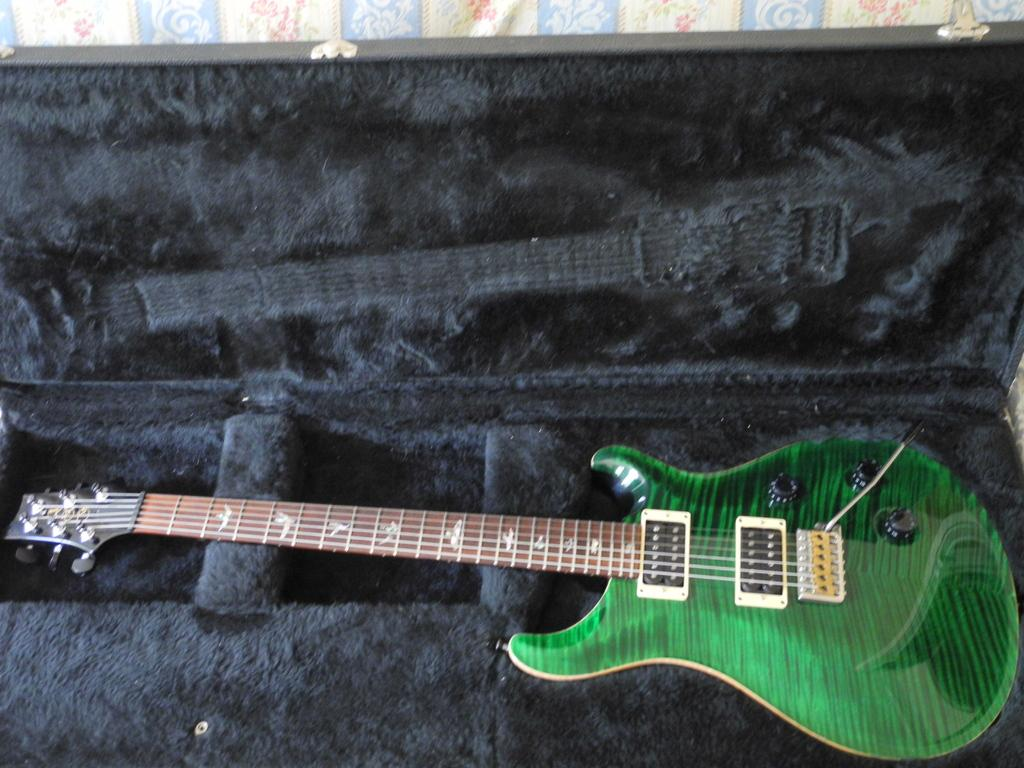What musical instrument is present in the image? There is a guitar in the image. How is the guitar being stored or transported in the image? The guitar is placed in a guitar box. What type of cork can be seen on the guitar strings in the image? There is no cork present on the guitar strings in the image. 